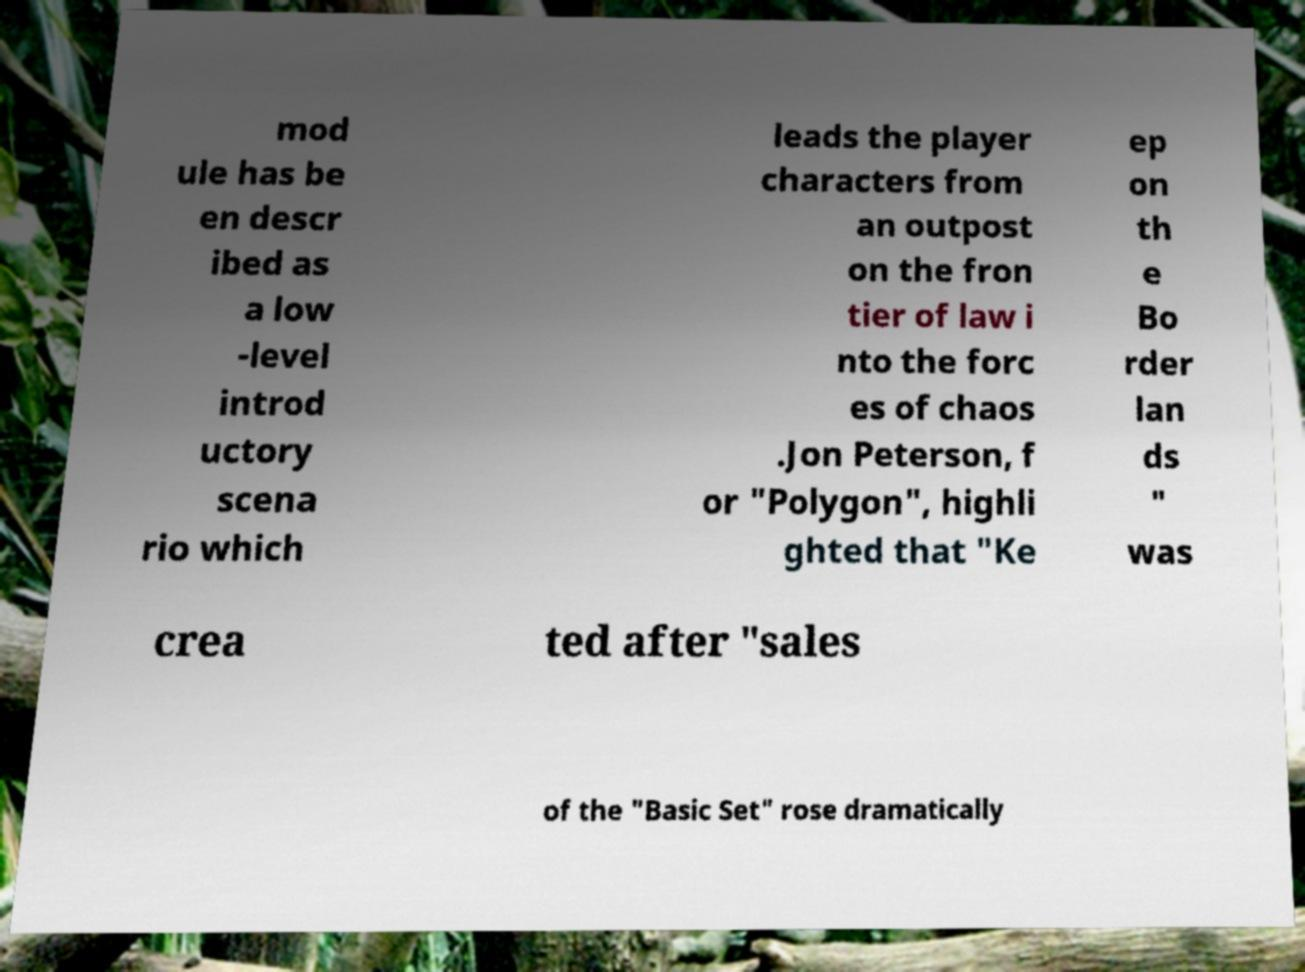Please read and relay the text visible in this image. What does it say? mod ule has be en descr ibed as a low -level introd uctory scena rio which leads the player characters from an outpost on the fron tier of law i nto the forc es of chaos .Jon Peterson, f or "Polygon", highli ghted that "Ke ep on th e Bo rder lan ds " was crea ted after "sales of the "Basic Set" rose dramatically 